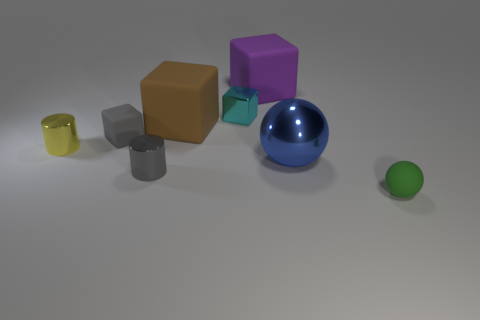Add 2 small green rubber blocks. How many objects exist? 10 Subtract all large brown blocks. How many blocks are left? 3 Subtract all brown cubes. How many cubes are left? 3 Subtract all brown cylinders. Subtract all yellow spheres. How many cylinders are left? 2 Subtract all cyan cubes. How many purple cylinders are left? 0 Subtract all gray objects. Subtract all tiny rubber cylinders. How many objects are left? 6 Add 6 big brown matte blocks. How many big brown matte blocks are left? 7 Add 5 tiny yellow cylinders. How many tiny yellow cylinders exist? 6 Subtract 1 gray blocks. How many objects are left? 7 Subtract all cylinders. How many objects are left? 6 